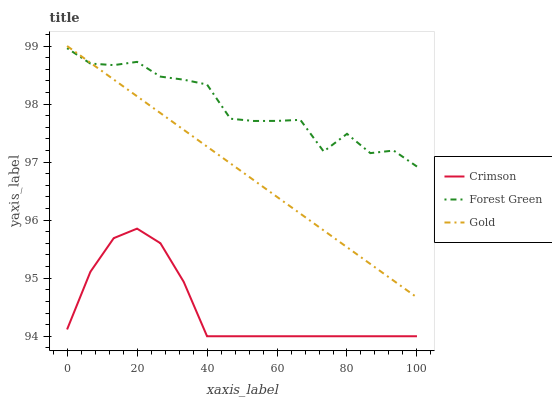Does Gold have the minimum area under the curve?
Answer yes or no. No. Does Gold have the maximum area under the curve?
Answer yes or no. No. Is Forest Green the smoothest?
Answer yes or no. No. Is Gold the roughest?
Answer yes or no. No. Does Gold have the lowest value?
Answer yes or no. No. Does Forest Green have the highest value?
Answer yes or no. No. Is Crimson less than Forest Green?
Answer yes or no. Yes. Is Forest Green greater than Crimson?
Answer yes or no. Yes. Does Crimson intersect Forest Green?
Answer yes or no. No. 